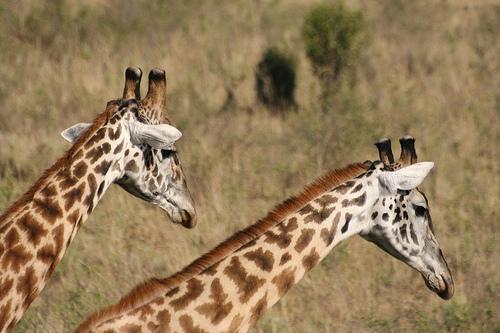How many giraffes are there?
Give a very brief answer. 2. How many giraffes in this image have both ears visible?
Give a very brief answer. 1. 